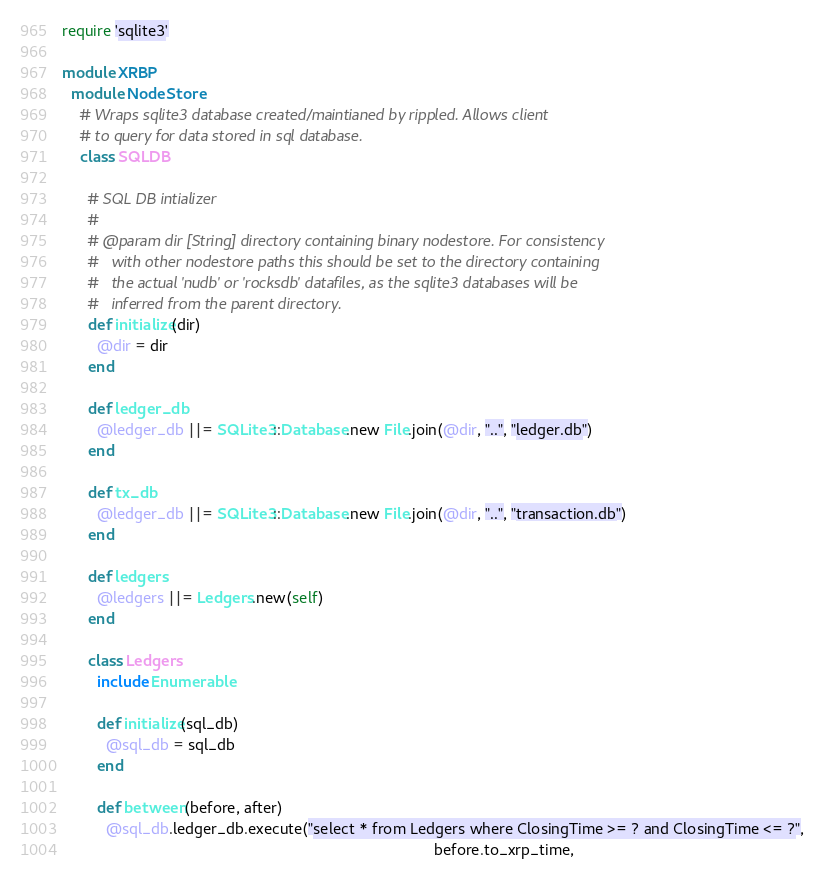Convert code to text. <code><loc_0><loc_0><loc_500><loc_500><_Ruby_>require 'sqlite3'

module XRBP
  module NodeStore
    # Wraps sqlite3 database created/maintianed by rippled. Allows client
    # to query for data stored in sql database.
    class SQLDB

      # SQL DB intializer
      #
      # @param dir [String] directory containing binary nodestore. For consistency
      #   with other nodestore paths this should be set to the directory containing
      #   the actual 'nudb' or 'rocksdb' datafiles, as the sqlite3 databases will be
      #   inferred from the parent directory.
      def initialize(dir)
        @dir = dir
      end

      def ledger_db
        @ledger_db ||= SQLite3::Database.new File.join(@dir, "..", "ledger.db")
      end

      def tx_db
        @ledger_db ||= SQLite3::Database.new File.join(@dir, "..", "transaction.db")
      end

      def ledgers
        @ledgers ||= Ledgers.new(self)
      end

      class Ledgers
        include Enumerable

        def initialize(sql_db)
          @sql_db = sql_db
        end

        def between(before, after)
          @sql_db.ledger_db.execute("select * from Ledgers where ClosingTime >= ? and ClosingTime <= ?",
                                                                                     before.to_xrp_time,</code> 